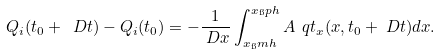Convert formula to latex. <formula><loc_0><loc_0><loc_500><loc_500>Q _ { i } ( t _ { 0 } + \ D t ) - Q _ { i } ( t _ { 0 } ) & = - \frac { 1 } { \ D x } \int _ { x _ { \i } m h } ^ { x _ { \i } p h } A \, \ q t _ { x } ( x , t _ { 0 } + \ D t ) d x .</formula> 